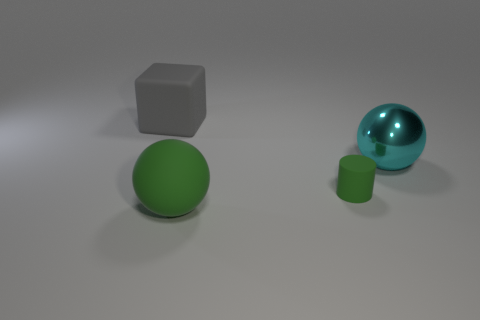There is another matte thing that is the same color as the small rubber object; what shape is it?
Your answer should be very brief. Sphere. Are there any large balls that have the same color as the big cube?
Ensure brevity in your answer.  No. How many objects are balls that are to the left of the tiny green cylinder or matte objects?
Ensure brevity in your answer.  3. Does the tiny cylinder have the same material as the large thing behind the large cyan sphere?
Provide a short and direct response. Yes. What is the size of the ball that is the same color as the small thing?
Keep it short and to the point. Large. Are there any yellow spheres that have the same material as the green cylinder?
Your answer should be compact. No. What number of things are large things that are behind the green rubber cylinder or things that are right of the gray rubber thing?
Your answer should be very brief. 4. Do the small matte thing and the big matte object that is in front of the big gray cube have the same shape?
Your answer should be very brief. No. What number of other objects are there of the same shape as the cyan metal object?
Your answer should be very brief. 1. What number of objects are either large cyan shiny objects or yellow objects?
Give a very brief answer. 1. 